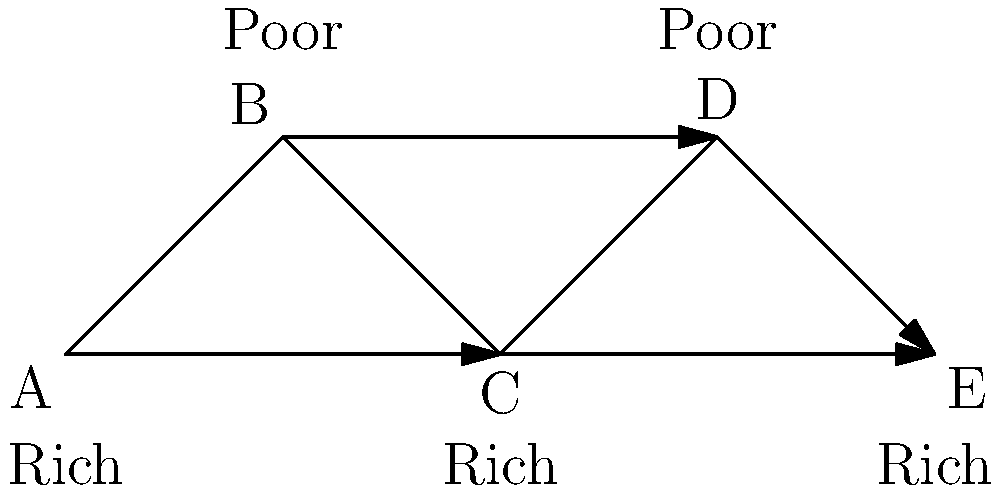Consider the trade network represented by the graph, where vertices A, C, and E are resource-rich regions, while B and D are resource-poor regions. Edges represent trade routes, with arrows indicating the direction of resource flow. What is the minimum number of edges that need to be removed to disconnect all resource-poor regions from resource-rich regions? To solve this problem, we need to analyze the connectivity between resource-rich and resource-poor regions:

1. Identify resource-rich regions: A, C, and E
2. Identify resource-poor regions: B and D

3. Analyze connections:
   - B is connected to A and C
   - D is connected to C and E

4. To disconnect all resource-poor regions:
   - We need to remove the edge B-A
   - We need to remove the edge B-C
   - We need to remove the edge D-C
   - We need to remove the edge D-E

5. Count the minimum number of edges to be removed:
   4 edges need to be removed to completely disconnect resource-poor regions from resource-rich regions.

6. Verify:
   After removing these 4 edges, B and D will be isolated from A, C, and E, achieving the desired disconnection.
Answer: 4 